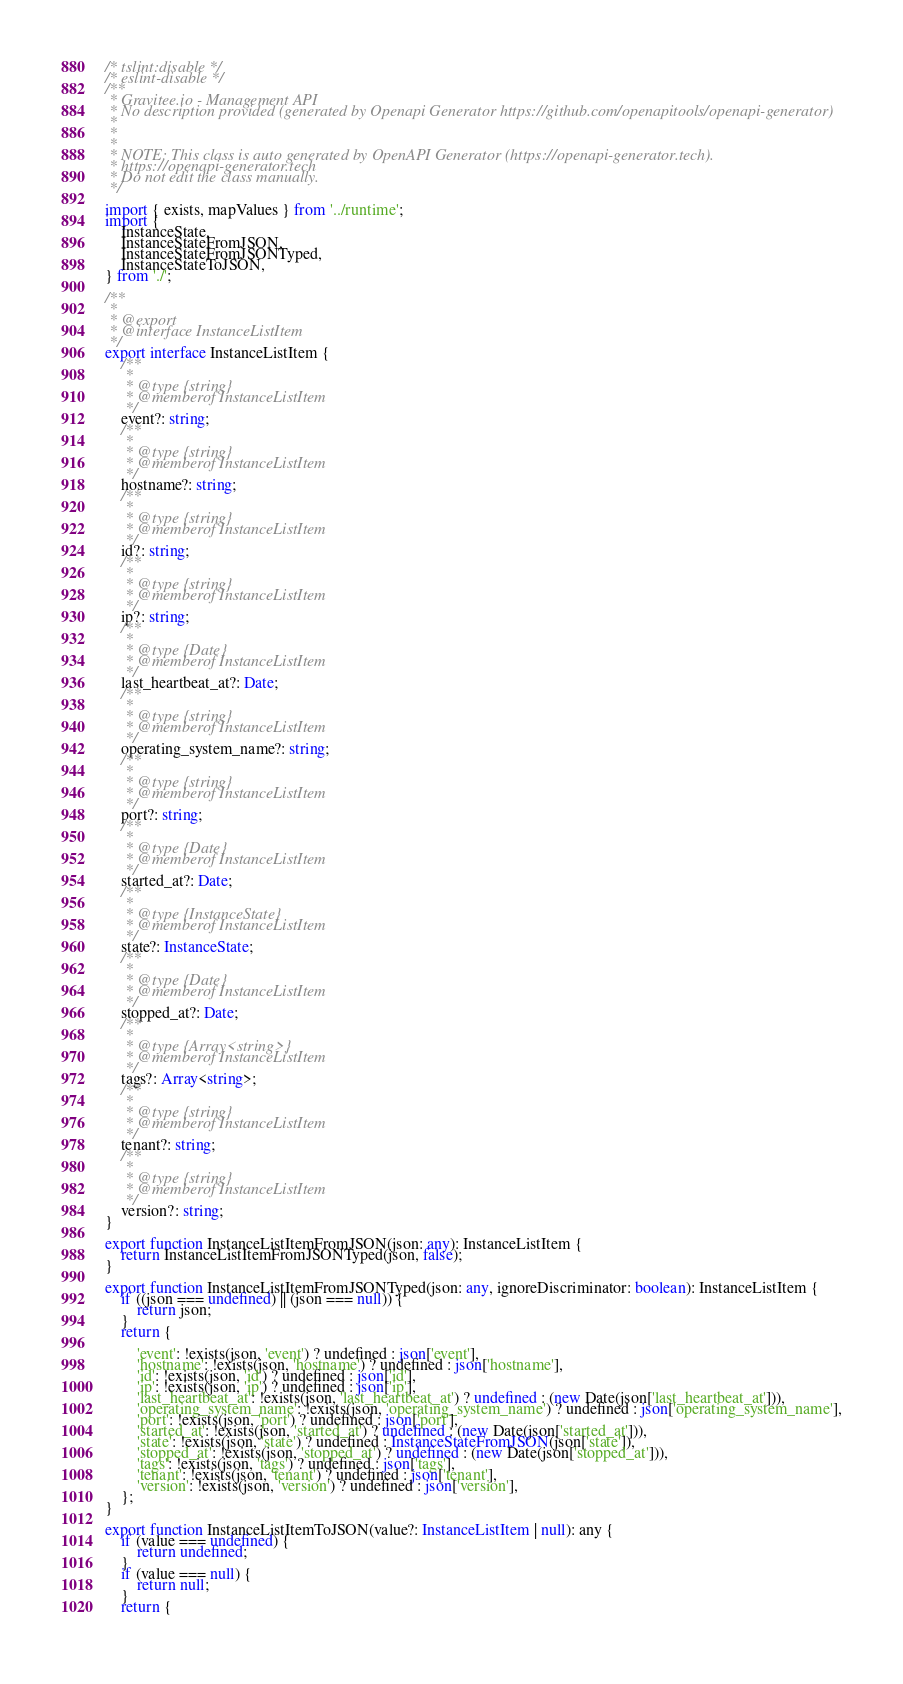Convert code to text. <code><loc_0><loc_0><loc_500><loc_500><_TypeScript_>/* tslint:disable */
/* eslint-disable */
/**
 * Gravitee.io - Management API
 * No description provided (generated by Openapi Generator https://github.com/openapitools/openapi-generator)
 *
 * 
 *
 * NOTE: This class is auto generated by OpenAPI Generator (https://openapi-generator.tech).
 * https://openapi-generator.tech
 * Do not edit the class manually.
 */

import { exists, mapValues } from '../runtime';
import {
    InstanceState,
    InstanceStateFromJSON,
    InstanceStateFromJSONTyped,
    InstanceStateToJSON,
} from './';

/**
 * 
 * @export
 * @interface InstanceListItem
 */
export interface InstanceListItem {
    /**
     * 
     * @type {string}
     * @memberof InstanceListItem
     */
    event?: string;
    /**
     * 
     * @type {string}
     * @memberof InstanceListItem
     */
    hostname?: string;
    /**
     * 
     * @type {string}
     * @memberof InstanceListItem
     */
    id?: string;
    /**
     * 
     * @type {string}
     * @memberof InstanceListItem
     */
    ip?: string;
    /**
     * 
     * @type {Date}
     * @memberof InstanceListItem
     */
    last_heartbeat_at?: Date;
    /**
     * 
     * @type {string}
     * @memberof InstanceListItem
     */
    operating_system_name?: string;
    /**
     * 
     * @type {string}
     * @memberof InstanceListItem
     */
    port?: string;
    /**
     * 
     * @type {Date}
     * @memberof InstanceListItem
     */
    started_at?: Date;
    /**
     * 
     * @type {InstanceState}
     * @memberof InstanceListItem
     */
    state?: InstanceState;
    /**
     * 
     * @type {Date}
     * @memberof InstanceListItem
     */
    stopped_at?: Date;
    /**
     * 
     * @type {Array<string>}
     * @memberof InstanceListItem
     */
    tags?: Array<string>;
    /**
     * 
     * @type {string}
     * @memberof InstanceListItem
     */
    tenant?: string;
    /**
     * 
     * @type {string}
     * @memberof InstanceListItem
     */
    version?: string;
}

export function InstanceListItemFromJSON(json: any): InstanceListItem {
    return InstanceListItemFromJSONTyped(json, false);
}

export function InstanceListItemFromJSONTyped(json: any, ignoreDiscriminator: boolean): InstanceListItem {
    if ((json === undefined) || (json === null)) {
        return json;
    }
    return {
        
        'event': !exists(json, 'event') ? undefined : json['event'],
        'hostname': !exists(json, 'hostname') ? undefined : json['hostname'],
        'id': !exists(json, 'id') ? undefined : json['id'],
        'ip': !exists(json, 'ip') ? undefined : json['ip'],
        'last_heartbeat_at': !exists(json, 'last_heartbeat_at') ? undefined : (new Date(json['last_heartbeat_at'])),
        'operating_system_name': !exists(json, 'operating_system_name') ? undefined : json['operating_system_name'],
        'port': !exists(json, 'port') ? undefined : json['port'],
        'started_at': !exists(json, 'started_at') ? undefined : (new Date(json['started_at'])),
        'state': !exists(json, 'state') ? undefined : InstanceStateFromJSON(json['state']),
        'stopped_at': !exists(json, 'stopped_at') ? undefined : (new Date(json['stopped_at'])),
        'tags': !exists(json, 'tags') ? undefined : json['tags'],
        'tenant': !exists(json, 'tenant') ? undefined : json['tenant'],
        'version': !exists(json, 'version') ? undefined : json['version'],
    };
}

export function InstanceListItemToJSON(value?: InstanceListItem | null): any {
    if (value === undefined) {
        return undefined;
    }
    if (value === null) {
        return null;
    }
    return {
        </code> 